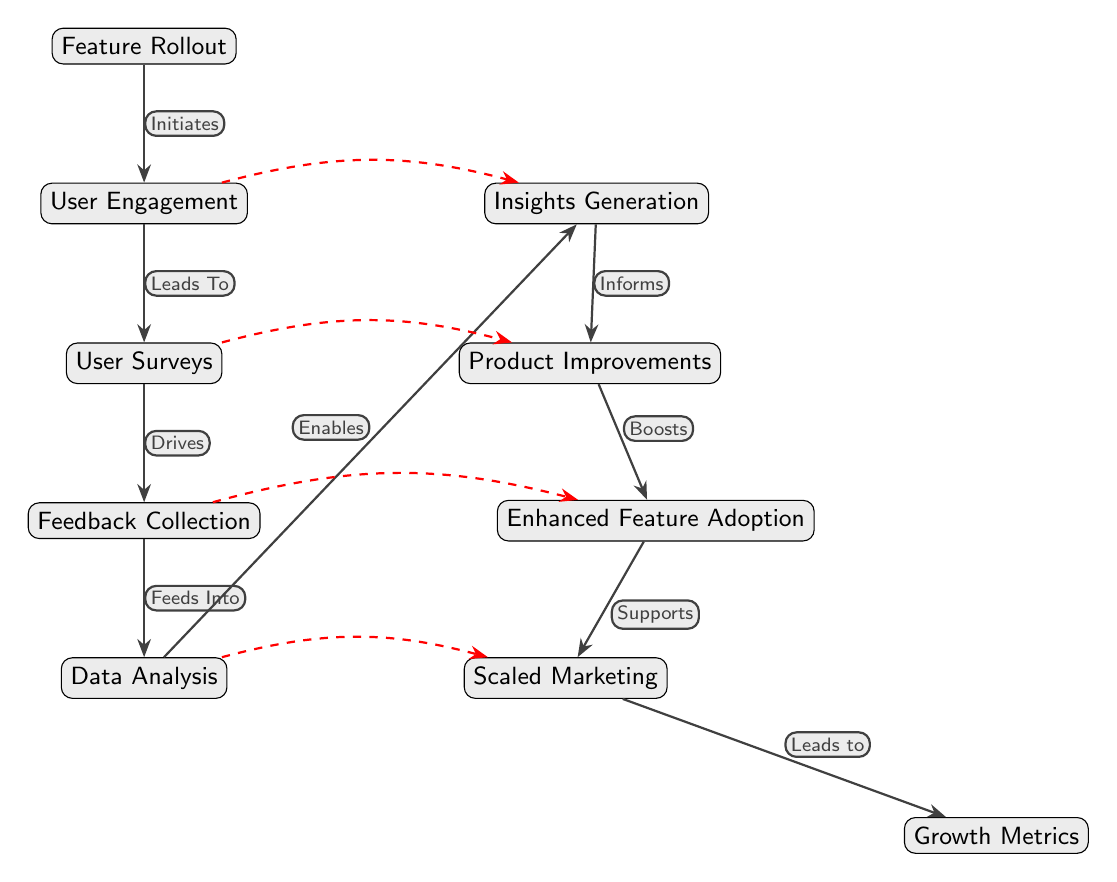What is the starting point of the diagram? The diagram begins with the "Feature Rollout" node, which initiates the entire process. This is the first node shown at the top.
Answer: Feature Rollout How many nodes are present in the diagram? Counting all the distinct nodes, we get a total of 6 nodes: Feature Rollout, User Engagement, User Surveys, Feedback Collection, Data Analysis, Insights Generation, Product Improvements, Enhanced Feature Adoption, Scaled Marketing, and Growth Metrics. Since Growth Metrics is not initially in the flow, there are 9 nodes in total.
Answer: 9 What does the "Feedback Collection" node feed into? The "Feedback Collection" node links to the "Data Analysis" node, indicating that feedback is collected and then utilized for analysis. This is shown by the directional edge connecting the two nodes.
Answer: Data Analysis How many edges are in the diagram? By counting the arrows (edges) present in the diagram, we find there are 8 directed connections, including the additional dashed connections between nodes for visual appeal.
Answer: 8 What does "Insights Generation" enable? The "Insights Generation" node enables "Product Improvements," which signifies that the insights gained from data analysis lead to enhancements in the product based on user feedback.
Answer: Product Improvements What relationship does "User Engagement" have with "Insights Generation"? "User Engagement" has a dashed edge (representing a less direct influence) that points to "Insights Generation," suggesting that user engagement also contributes informally to generating insights, although primarily through the flow of data.
Answer: Contributes Which node supports "Scaled Marketing"? The "Enhanced Feature Adoption" node supports "Scaled Marketing," implying that as feature adoption improves, it also positively influences marketing efforts and outreach strategies.
Answer: Enhanced Feature Adoption How does "Data Analysis" influence marketing strategies? "Data Analysis" leads to "Scaled Marketing," meaning that insights drawn from data analysis are critical for shaping and improving marketing strategies, thereby supporting growth efforts.
Answer: Supports What impact does "Product Improvements" have on feature adoption? "Product Improvements" boosts "Enhanced Feature Adoption," indicating that enhancements made to the product based on feedback directly influence the adoption rates of features by users.
Answer: Boosts What is indicated by the dashed edges in the diagram? The dashed edges signify less direct relationships or influences between nodes, showing that even though these interactions are not primary, they still play a role in the overall process, enhancing understanding of connections in strategy execution.
Answer: Less direct relationships 